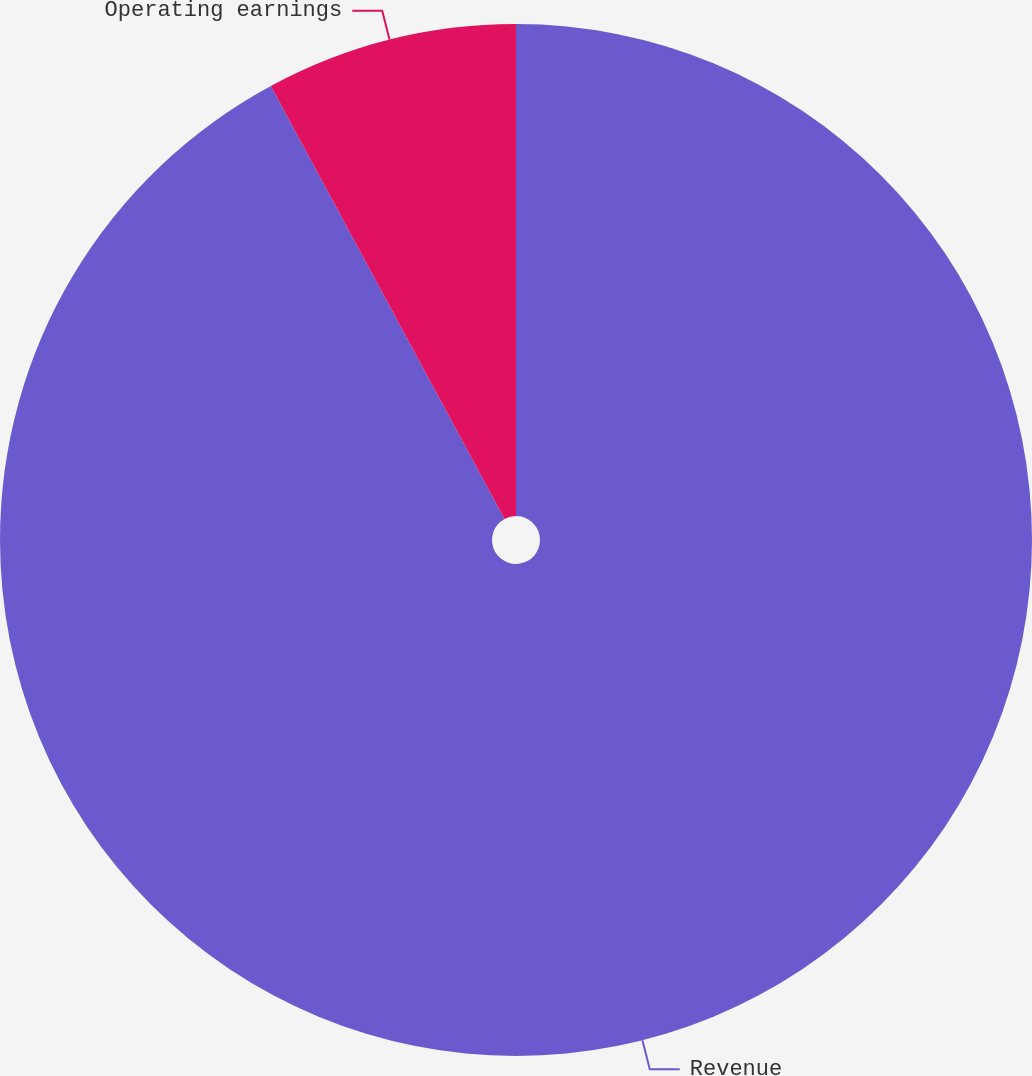Convert chart. <chart><loc_0><loc_0><loc_500><loc_500><pie_chart><fcel>Revenue<fcel>Operating earnings<nl><fcel>92.12%<fcel>7.88%<nl></chart> 